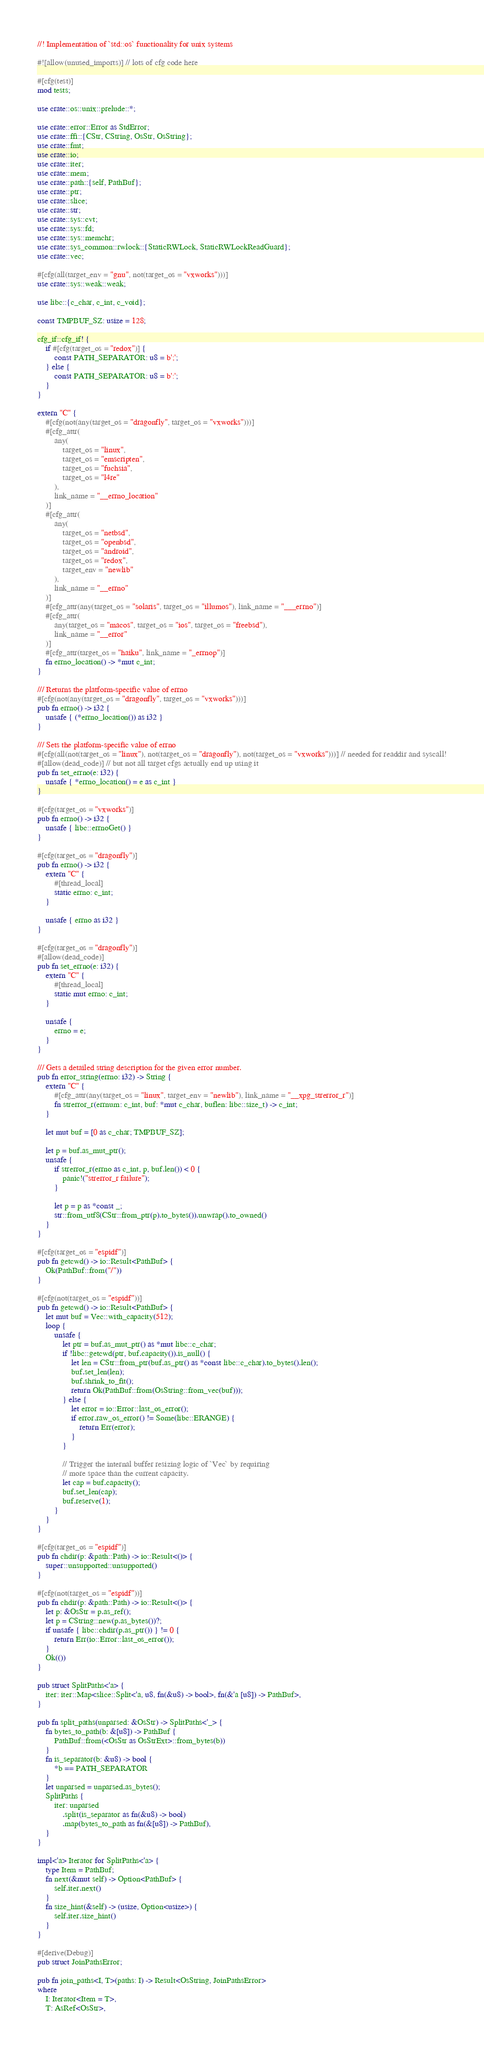<code> <loc_0><loc_0><loc_500><loc_500><_Rust_>//! Implementation of `std::os` functionality for unix systems

#![allow(unused_imports)] // lots of cfg code here

#[cfg(test)]
mod tests;

use crate::os::unix::prelude::*;

use crate::error::Error as StdError;
use crate::ffi::{CStr, CString, OsStr, OsString};
use crate::fmt;
use crate::io;
use crate::iter;
use crate::mem;
use crate::path::{self, PathBuf};
use crate::ptr;
use crate::slice;
use crate::str;
use crate::sys::cvt;
use crate::sys::fd;
use crate::sys::memchr;
use crate::sys_common::rwlock::{StaticRWLock, StaticRWLockReadGuard};
use crate::vec;

#[cfg(all(target_env = "gnu", not(target_os = "vxworks")))]
use crate::sys::weak::weak;

use libc::{c_char, c_int, c_void};

const TMPBUF_SZ: usize = 128;

cfg_if::cfg_if! {
    if #[cfg(target_os = "redox")] {
        const PATH_SEPARATOR: u8 = b';';
    } else {
        const PATH_SEPARATOR: u8 = b':';
    }
}

extern "C" {
    #[cfg(not(any(target_os = "dragonfly", target_os = "vxworks")))]
    #[cfg_attr(
        any(
            target_os = "linux",
            target_os = "emscripten",
            target_os = "fuchsia",
            target_os = "l4re"
        ),
        link_name = "__errno_location"
    )]
    #[cfg_attr(
        any(
            target_os = "netbsd",
            target_os = "openbsd",
            target_os = "android",
            target_os = "redox",
            target_env = "newlib"
        ),
        link_name = "__errno"
    )]
    #[cfg_attr(any(target_os = "solaris", target_os = "illumos"), link_name = "___errno")]
    #[cfg_attr(
        any(target_os = "macos", target_os = "ios", target_os = "freebsd"),
        link_name = "__error"
    )]
    #[cfg_attr(target_os = "haiku", link_name = "_errnop")]
    fn errno_location() -> *mut c_int;
}

/// Returns the platform-specific value of errno
#[cfg(not(any(target_os = "dragonfly", target_os = "vxworks")))]
pub fn errno() -> i32 {
    unsafe { (*errno_location()) as i32 }
}

/// Sets the platform-specific value of errno
#[cfg(all(not(target_os = "linux"), not(target_os = "dragonfly"), not(target_os = "vxworks")))] // needed for readdir and syscall!
#[allow(dead_code)] // but not all target cfgs actually end up using it
pub fn set_errno(e: i32) {
    unsafe { *errno_location() = e as c_int }
}

#[cfg(target_os = "vxworks")]
pub fn errno() -> i32 {
    unsafe { libc::errnoGet() }
}

#[cfg(target_os = "dragonfly")]
pub fn errno() -> i32 {
    extern "C" {
        #[thread_local]
        static errno: c_int;
    }

    unsafe { errno as i32 }
}

#[cfg(target_os = "dragonfly")]
#[allow(dead_code)]
pub fn set_errno(e: i32) {
    extern "C" {
        #[thread_local]
        static mut errno: c_int;
    }

    unsafe {
        errno = e;
    }
}

/// Gets a detailed string description for the given error number.
pub fn error_string(errno: i32) -> String {
    extern "C" {
        #[cfg_attr(any(target_os = "linux", target_env = "newlib"), link_name = "__xpg_strerror_r")]
        fn strerror_r(errnum: c_int, buf: *mut c_char, buflen: libc::size_t) -> c_int;
    }

    let mut buf = [0 as c_char; TMPBUF_SZ];

    let p = buf.as_mut_ptr();
    unsafe {
        if strerror_r(errno as c_int, p, buf.len()) < 0 {
            panic!("strerror_r failure");
        }

        let p = p as *const _;
        str::from_utf8(CStr::from_ptr(p).to_bytes()).unwrap().to_owned()
    }
}

#[cfg(target_os = "espidf")]
pub fn getcwd() -> io::Result<PathBuf> {
    Ok(PathBuf::from("/"))
}

#[cfg(not(target_os = "espidf"))]
pub fn getcwd() -> io::Result<PathBuf> {
    let mut buf = Vec::with_capacity(512);
    loop {
        unsafe {
            let ptr = buf.as_mut_ptr() as *mut libc::c_char;
            if !libc::getcwd(ptr, buf.capacity()).is_null() {
                let len = CStr::from_ptr(buf.as_ptr() as *const libc::c_char).to_bytes().len();
                buf.set_len(len);
                buf.shrink_to_fit();
                return Ok(PathBuf::from(OsString::from_vec(buf)));
            } else {
                let error = io::Error::last_os_error();
                if error.raw_os_error() != Some(libc::ERANGE) {
                    return Err(error);
                }
            }

            // Trigger the internal buffer resizing logic of `Vec` by requiring
            // more space than the current capacity.
            let cap = buf.capacity();
            buf.set_len(cap);
            buf.reserve(1);
        }
    }
}

#[cfg(target_os = "espidf")]
pub fn chdir(p: &path::Path) -> io::Result<()> {
    super::unsupported::unsupported()
}

#[cfg(not(target_os = "espidf"))]
pub fn chdir(p: &path::Path) -> io::Result<()> {
    let p: &OsStr = p.as_ref();
    let p = CString::new(p.as_bytes())?;
    if unsafe { libc::chdir(p.as_ptr()) } != 0 {
        return Err(io::Error::last_os_error());
    }
    Ok(())
}

pub struct SplitPaths<'a> {
    iter: iter::Map<slice::Split<'a, u8, fn(&u8) -> bool>, fn(&'a [u8]) -> PathBuf>,
}

pub fn split_paths(unparsed: &OsStr) -> SplitPaths<'_> {
    fn bytes_to_path(b: &[u8]) -> PathBuf {
        PathBuf::from(<OsStr as OsStrExt>::from_bytes(b))
    }
    fn is_separator(b: &u8) -> bool {
        *b == PATH_SEPARATOR
    }
    let unparsed = unparsed.as_bytes();
    SplitPaths {
        iter: unparsed
            .split(is_separator as fn(&u8) -> bool)
            .map(bytes_to_path as fn(&[u8]) -> PathBuf),
    }
}

impl<'a> Iterator for SplitPaths<'a> {
    type Item = PathBuf;
    fn next(&mut self) -> Option<PathBuf> {
        self.iter.next()
    }
    fn size_hint(&self) -> (usize, Option<usize>) {
        self.iter.size_hint()
    }
}

#[derive(Debug)]
pub struct JoinPathsError;

pub fn join_paths<I, T>(paths: I) -> Result<OsString, JoinPathsError>
where
    I: Iterator<Item = T>,
    T: AsRef<OsStr>,</code> 